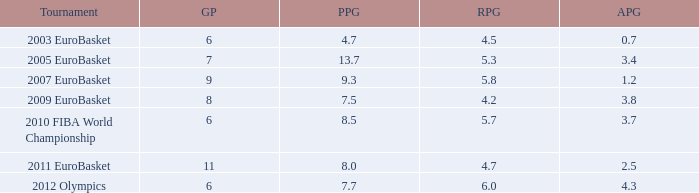How may assists per game have 7.7 points per game? 4.3. 